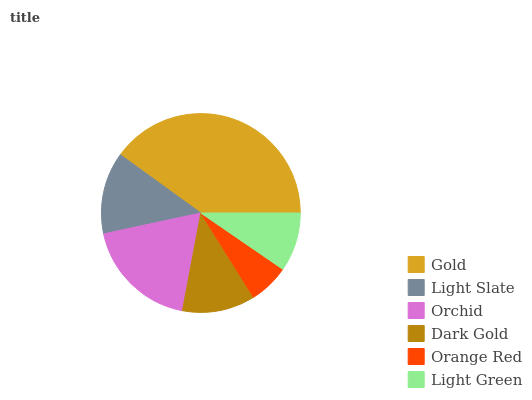Is Orange Red the minimum?
Answer yes or no. Yes. Is Gold the maximum?
Answer yes or no. Yes. Is Light Slate the minimum?
Answer yes or no. No. Is Light Slate the maximum?
Answer yes or no. No. Is Gold greater than Light Slate?
Answer yes or no. Yes. Is Light Slate less than Gold?
Answer yes or no. Yes. Is Light Slate greater than Gold?
Answer yes or no. No. Is Gold less than Light Slate?
Answer yes or no. No. Is Light Slate the high median?
Answer yes or no. Yes. Is Dark Gold the low median?
Answer yes or no. Yes. Is Orange Red the high median?
Answer yes or no. No. Is Gold the low median?
Answer yes or no. No. 